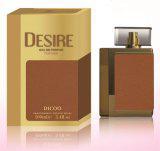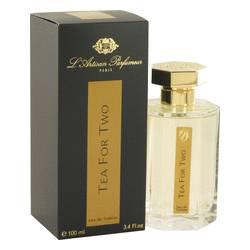The first image is the image on the left, the second image is the image on the right. Assess this claim about the two images: "One image shows a silver cylinder shape next to a silver upright box.". Correct or not? Answer yes or no. No. The first image is the image on the left, the second image is the image on the right. Considering the images on both sides, is "There are more containers in the image on the right." valid? Answer yes or no. No. 